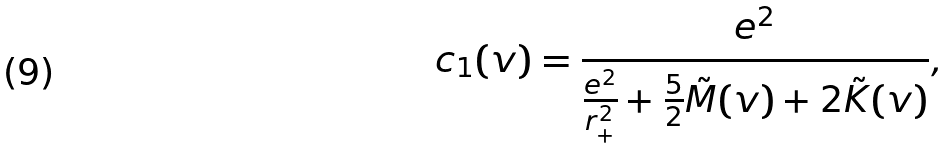Convert formula to latex. <formula><loc_0><loc_0><loc_500><loc_500>c _ { 1 } ( v ) = \frac { e ^ { 2 } } { \frac { e ^ { 2 } } { r _ { + } ^ { 2 } } + \frac { 5 } { 2 } \tilde { M } ( v ) + 2 \tilde { K } ( v ) } ,</formula> 